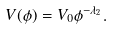<formula> <loc_0><loc_0><loc_500><loc_500>V ( \phi ) = V _ { 0 } \phi ^ { - \lambda _ { 2 } } .</formula> 